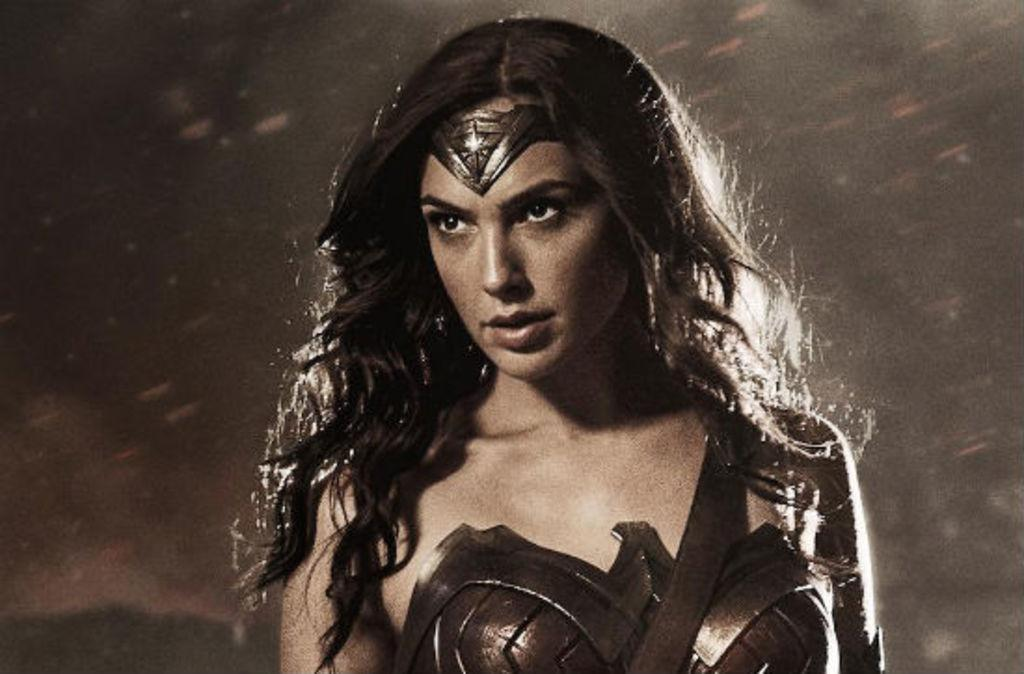What is the main subject of the image? There is a woman standing in the image. What can be observed about the background of the image? The background of the image is black in color. Can you describe the lighting conditions in the image? The image was taken in a dark environment. How many books are visible on the woman's head in the image? There are no books visible on the woman's head in the image. What type of money is being exchanged between the woman and another person in the image? There is no exchange of money or any other transaction depicted in the image. 